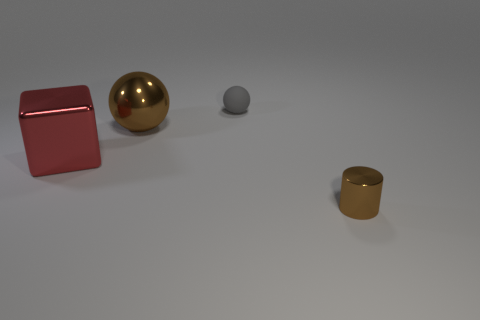How many things are either small objects in front of the gray rubber thing or small gray matte objects?
Your response must be concise. 2. Are there any big red rubber objects that have the same shape as the small brown shiny thing?
Offer a terse response. No. Are there the same number of small metal cylinders on the left side of the big red thing and tiny cyan metal cylinders?
Give a very brief answer. Yes. What is the shape of the other thing that is the same color as the small metal object?
Your response must be concise. Sphere. How many gray rubber things have the same size as the red block?
Keep it short and to the point. 0. What number of big metallic objects are in front of the tiny brown metallic thing?
Provide a succinct answer. 0. There is a brown object that is in front of the brown object left of the small sphere; what is its material?
Provide a succinct answer. Metal. Are there any other large metallic blocks of the same color as the large cube?
Keep it short and to the point. No. The red block that is made of the same material as the small brown cylinder is what size?
Keep it short and to the point. Large. Is there any other thing of the same color as the cylinder?
Your response must be concise. Yes. 